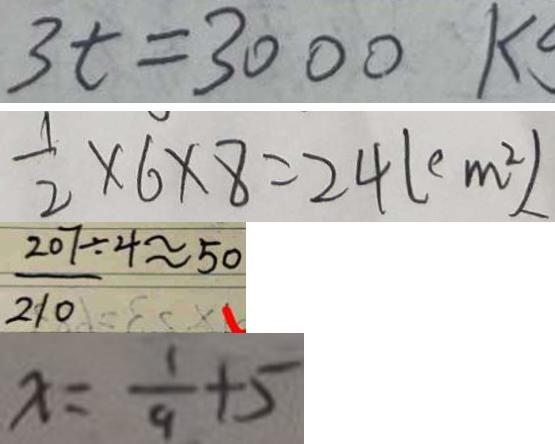Convert formula to latex. <formula><loc_0><loc_0><loc_500><loc_500>3 t = 3 0 0 0 k 
 \frac { 1 } { 2 } \times 6 \times 8 = 2 4 ( c m ^ { 2 } ) 
 \frac { 2 0 7 } { 2 1 0 } \div 4 \approx 5 0 
 x = \frac { 1 } { 9 } + 5</formula> 